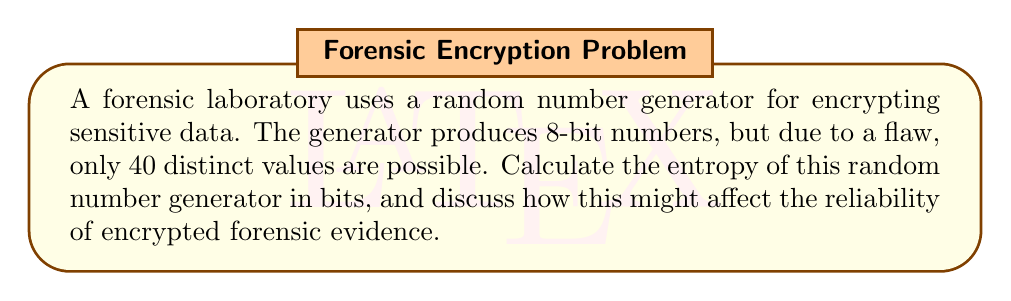Provide a solution to this math problem. To calculate the entropy of the random number generator, we'll follow these steps:

1) Entropy is a measure of uncertainty or randomness in a system. For a discrete random variable, it's calculated using the formula:

   $$H = -\sum_{i=1}^{n} p_i \log_2(p_i)$$

   where $p_i$ is the probability of outcome $i$, and $n$ is the number of possible outcomes.

2) In this case, we have 40 distinct possible values, and assuming they are equally likely (which gives maximum entropy for a given number of outcomes), each value has a probability of $\frac{1}{40}$.

3) Substituting into the entropy formula:

   $$H = -\sum_{i=1}^{40} \frac{1}{40} \log_2(\frac{1}{40})$$

4) Since all terms in the sum are identical, we can simplify:

   $$H = -40 \cdot \frac{1}{40} \log_2(\frac{1}{40}) = -\log_2(\frac{1}{40})$$

5) Using the logarithm property $\log_a(\frac{1}{x}) = -\log_a(x)$, we get:

   $$H = \log_2(40)$$

6) Calculating this:

   $$H \approx 5.32 \text{ bits}$$

This low entropy could significantly affect the reliability of encrypted forensic evidence. An ideal 8-bit random number generator should have an entropy of 8 bits. The reduced entropy means the encryption is much weaker than expected, making it potentially vulnerable to cryptanalysis. This could lead to unauthorized access to sensitive forensic data or challenges to the integrity of encrypted evidence in legal proceedings.
Answer: $5.32$ bits 